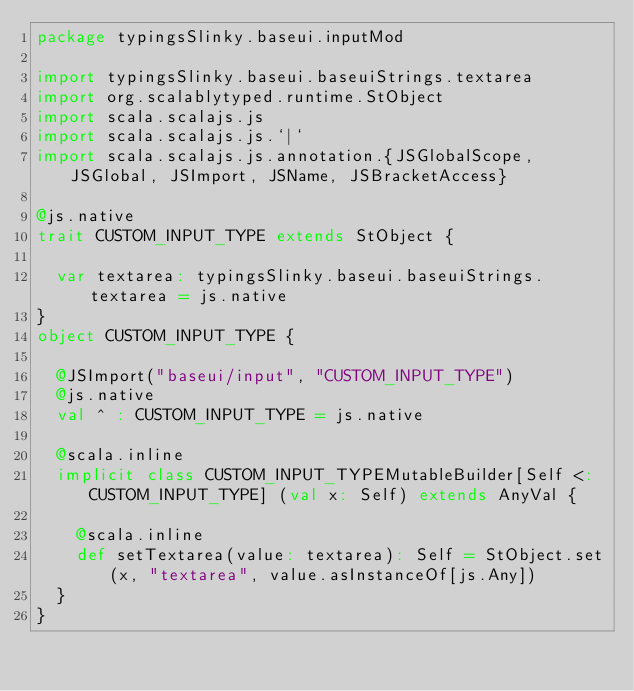Convert code to text. <code><loc_0><loc_0><loc_500><loc_500><_Scala_>package typingsSlinky.baseui.inputMod

import typingsSlinky.baseui.baseuiStrings.textarea
import org.scalablytyped.runtime.StObject
import scala.scalajs.js
import scala.scalajs.js.`|`
import scala.scalajs.js.annotation.{JSGlobalScope, JSGlobal, JSImport, JSName, JSBracketAccess}

@js.native
trait CUSTOM_INPUT_TYPE extends StObject {
  
  var textarea: typingsSlinky.baseui.baseuiStrings.textarea = js.native
}
object CUSTOM_INPUT_TYPE {
  
  @JSImport("baseui/input", "CUSTOM_INPUT_TYPE")
  @js.native
  val ^ : CUSTOM_INPUT_TYPE = js.native
  
  @scala.inline
  implicit class CUSTOM_INPUT_TYPEMutableBuilder[Self <: CUSTOM_INPUT_TYPE] (val x: Self) extends AnyVal {
    
    @scala.inline
    def setTextarea(value: textarea): Self = StObject.set(x, "textarea", value.asInstanceOf[js.Any])
  }
}
</code> 